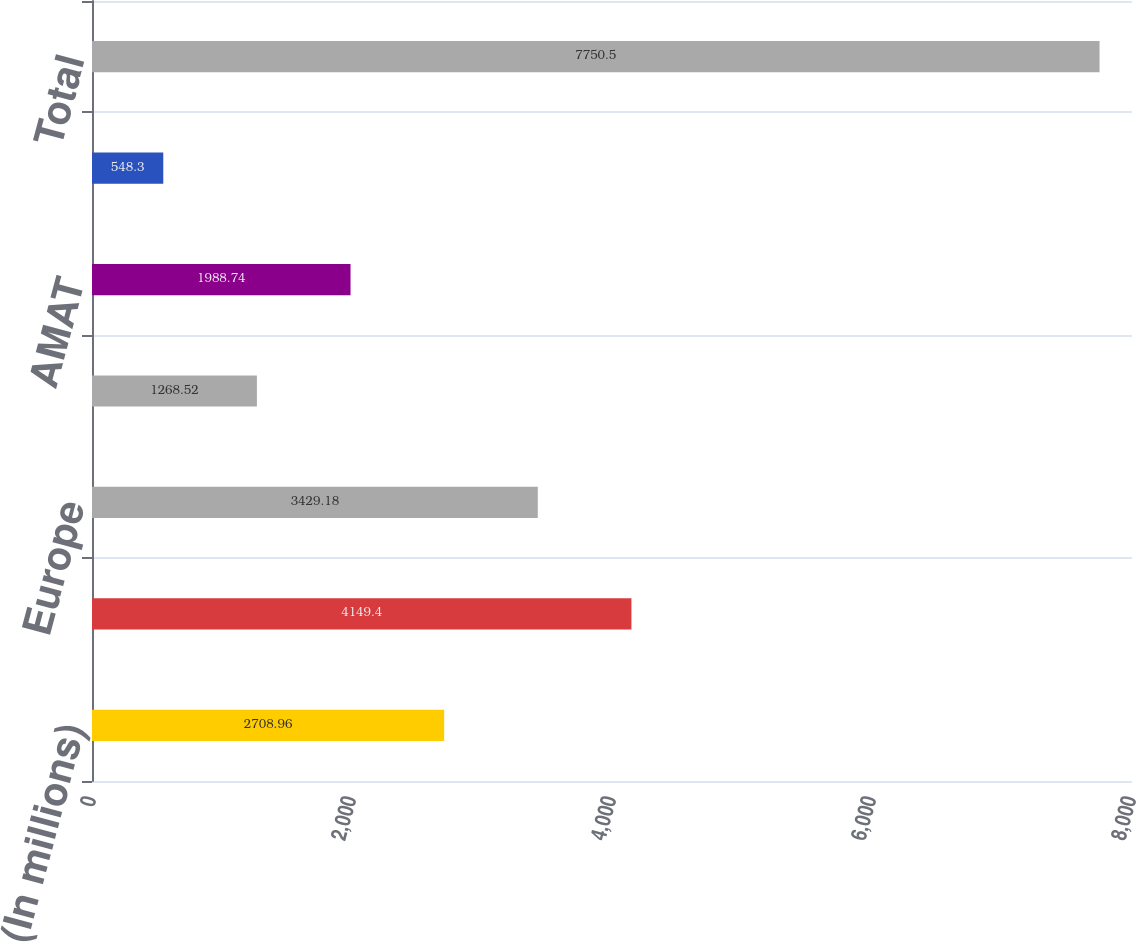Convert chart to OTSL. <chart><loc_0><loc_0><loc_500><loc_500><bar_chart><fcel>(In millions)<fcel>North America<fcel>Europe<fcel>Latin America<fcel>AMAT<fcel>JANZ<fcel>Total<nl><fcel>2708.96<fcel>4149.4<fcel>3429.18<fcel>1268.52<fcel>1988.74<fcel>548.3<fcel>7750.5<nl></chart> 